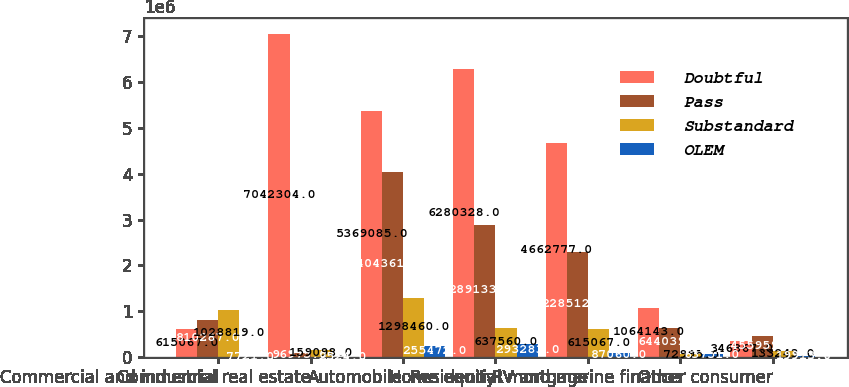Convert chart. <chart><loc_0><loc_0><loc_500><loc_500><stacked_bar_chart><ecel><fcel>Commercial and industrial<fcel>Commercial real estate<fcel>Automobile<fcel>Home equity<fcel>Residential mortgage<fcel>RV and marine finance<fcel>Other consumer<nl><fcel>Doubtful<fcel>615067<fcel>7.0423e+06<fcel>5.36908e+06<fcel>6.28033e+06<fcel>4.66278e+06<fcel>1.06414e+06<fcel>346867<nl><fcel>Pass<fcel>810287<fcel>96975<fcel>4.04361e+06<fcel>2.89133e+06<fcel>2.28512e+06<fcel>644039<fcel>455959<nl><fcel>Substandard<fcel>1.02882e+06<fcel>159098<fcel>1.29846e+06<fcel>637560<fcel>615067<fcel>72995<fcel>133243<nl><fcel>OLEM<fcel>7721<fcel>2524<fcel>255472<fcel>293283<fcel>87060<fcel>63751<fcel>19913<nl></chart> 